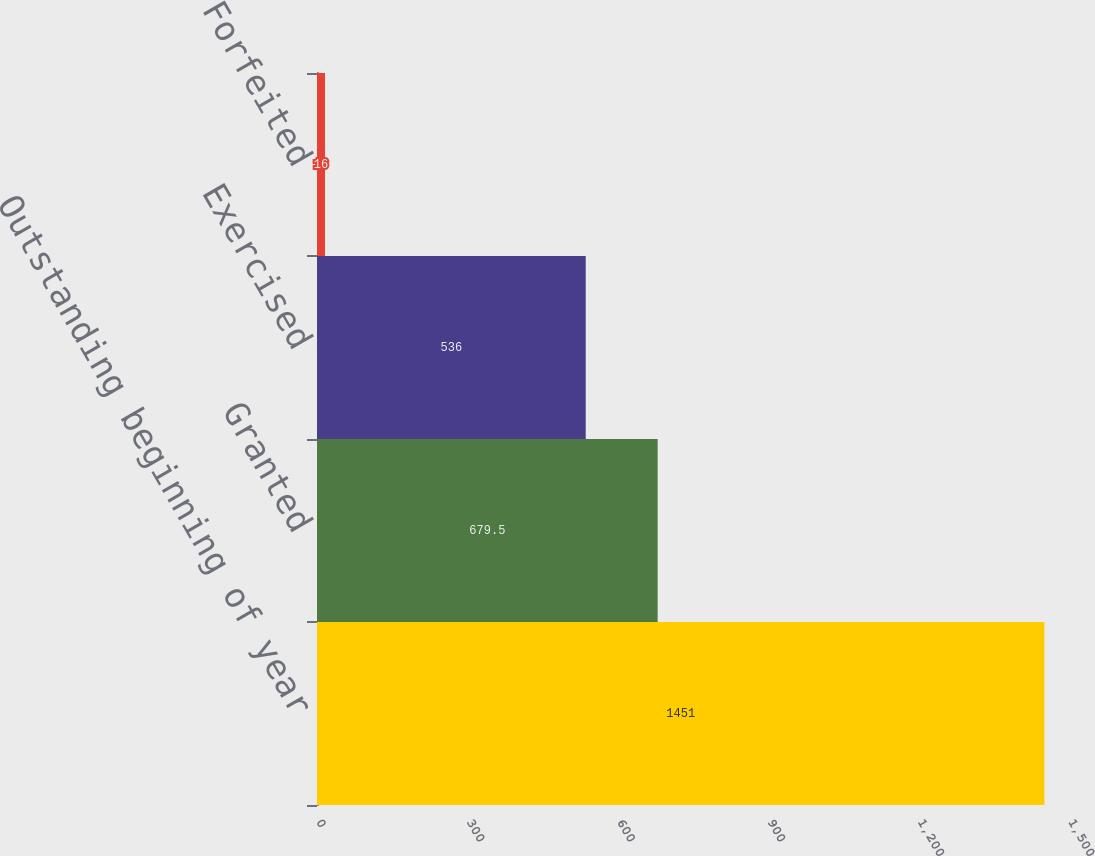<chart> <loc_0><loc_0><loc_500><loc_500><bar_chart><fcel>Outstanding beginning of year<fcel>Granted<fcel>Exercised<fcel>Forfeited<nl><fcel>1451<fcel>679.5<fcel>536<fcel>16<nl></chart> 